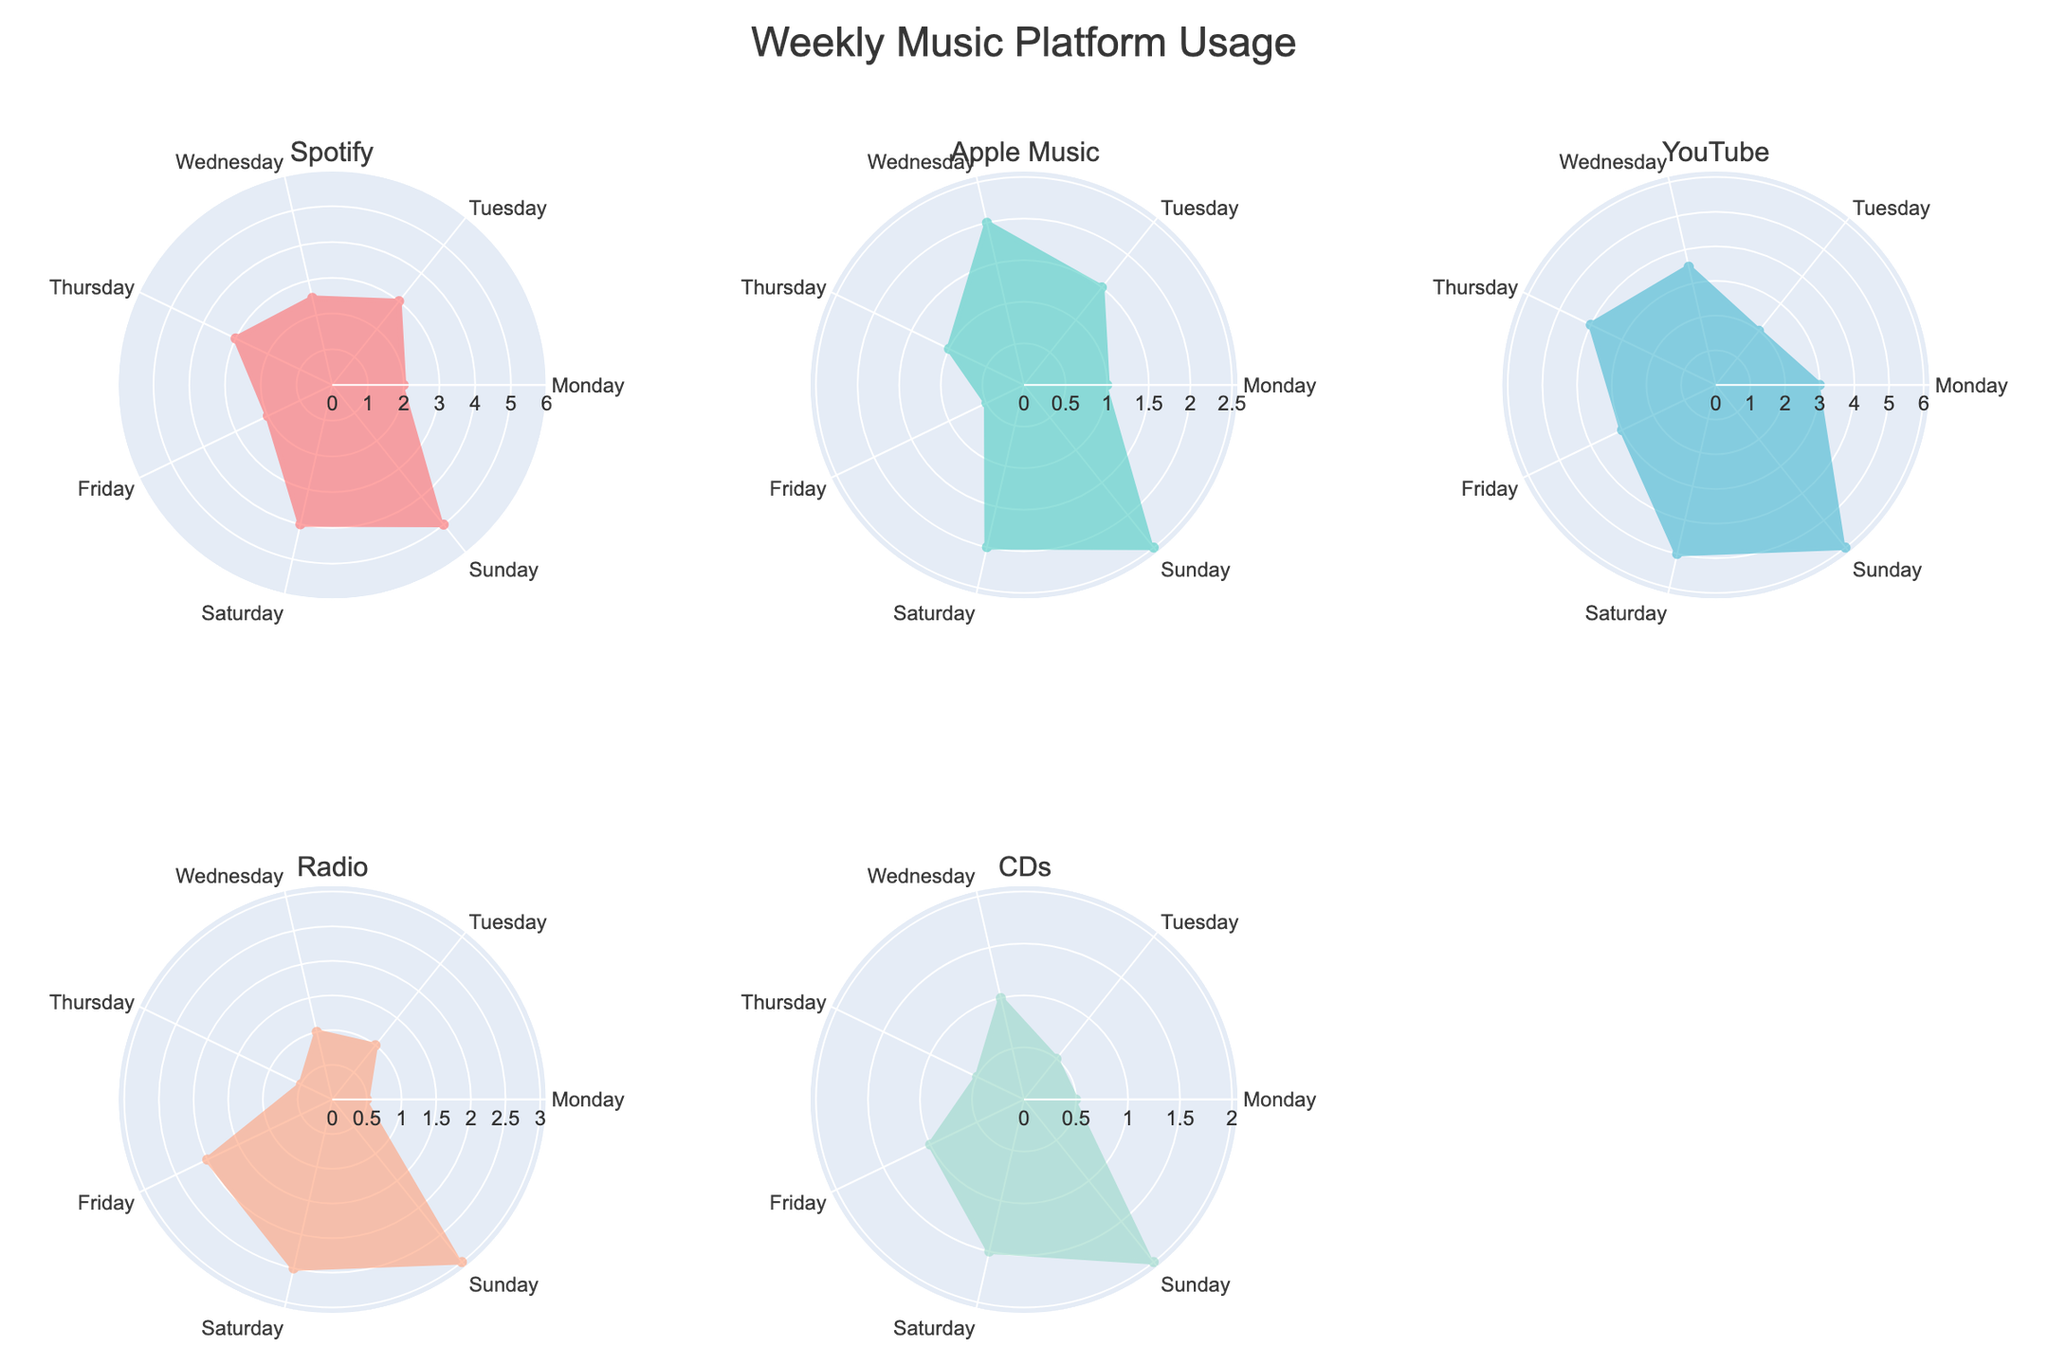What's the highest daily usage hour for Spotify? Look at the 'Spotify' subplot and identify the highest point. The maximum usage is on Sunday with 5 hours.
Answer: 5 Which platform has the highest usage on Saturday? Compare the 'Saturday' points across all subplots. YouTube shows the highest usage with 5 hours on that day.
Answer: YouTube How many hours do you use Apple Music on Wednesday and Sunday combined? Sum the usage hours from the 'Apple Music' subplot on Wednesday (2 hours) and Sunday (2.5 hours). The total is 2 + 2.5 = 4.5 hours.
Answer: 4.5 On which day is Radio usage the lowest? Look at the 'Radio' subplot and identify the lowest point. The minimum usage is on Monday and Thursday with 0.5 hours each.
Answer: Monday and Thursday Which two platforms have usage exceeding 4 hours on any given day? Check all subplots for usage above 4 hours on any day. Both Spotify and YouTube exceed this threshold on certain days.
Answer: Spotify and YouTube What is the total usage for CDs over the weekend (Saturday and Sunday)? Sum the usage hours for CDs during Saturday (1.5 hours) and Sunday (2 hours). The total is 1.5 + 2 = 3.5 hours.
Answer: 3.5 Is Apple Music ever used more than Spotify on any day? Compare Apple Music and Spotify usage on all days. No, Spotify is always used more than Apple Music.
Answer: No On which day is YouTube usage the highest, and what is the value? Look at the 'YouTube' subplot and identify the highest point. The maximum usage is on Sunday with 6 hours.
Answer: Sunday, 6 hours What is the variance in Radio usage throughout the week? Calculate the variance for Radio usage (0.5, 1, 1, 0.5, 2, 2.5, 3). Mean is (0.5+1+1+0.5+2+2.5+3)/7 = 1.5. Variance is [(0.5-1.5)² + (1-1.5)² + (1-1.5)² + (0.5-1.5)² + (2-1.5)² + (2.5-1.5)² + (3-1.5)²] / 7 = 0.857.
Answer: 0.857 